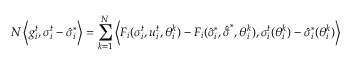Convert formula to latex. <formula><loc_0><loc_0><loc_500><loc_500>N \left < g _ { i } ^ { t } , \sigma _ { i } ^ { t } - \hat { \sigma } _ { i } ^ { * } \right > = \sum _ { k = 1 } ^ { N } \left < F _ { i } ( \sigma _ { i } ^ { t } , u _ { i } ^ { t } , \theta _ { i } ^ { k } ) - F _ { i } ( \hat { \sigma } _ { i } ^ { * } , \hat { \bar { \sigma } } ^ { * } , \theta _ { i } ^ { k } ) , \sigma _ { i } ^ { t } ( \theta _ { i } ^ { k } ) - \hat { \sigma } _ { i } ^ { * } ( \theta _ { i } ^ { k } ) \right ></formula> 